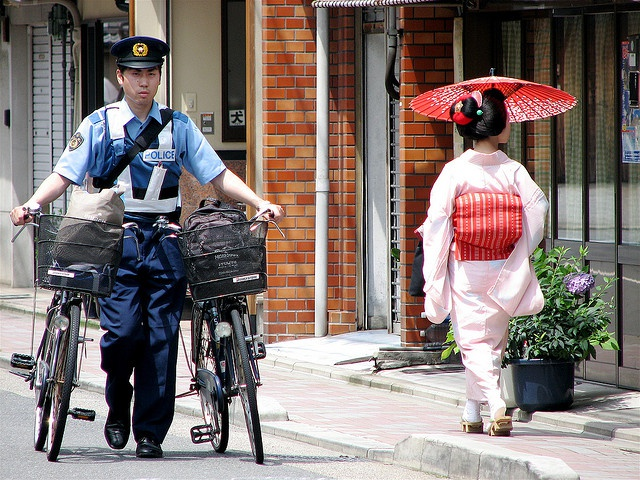Describe the objects in this image and their specific colors. I can see people in black, white, navy, and gray tones, people in black, white, lightpink, and darkgray tones, bicycle in black, gray, lightgray, and darkgray tones, bicycle in black, gray, darkgray, and lightgray tones, and potted plant in black, gray, darkgreen, and green tones in this image. 